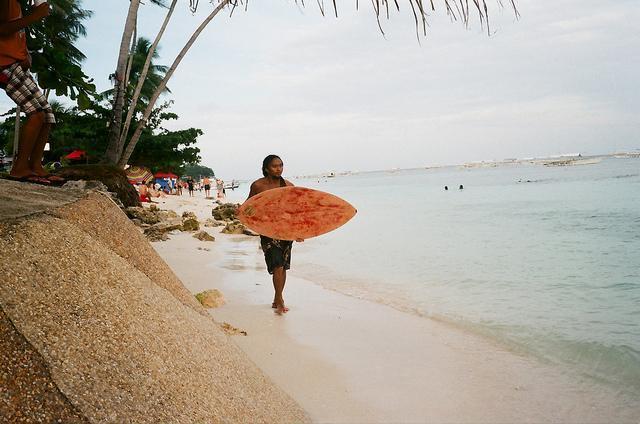How many people can you see?
Give a very brief answer. 2. How many cars have zebra stripes?
Give a very brief answer. 0. 